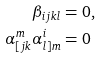<formula> <loc_0><loc_0><loc_500><loc_500>\beta _ { i j k l } & = 0 , \\ \alpha ^ { m } _ { [ j k } \alpha ^ { i } _ { l ] m } & = 0</formula> 